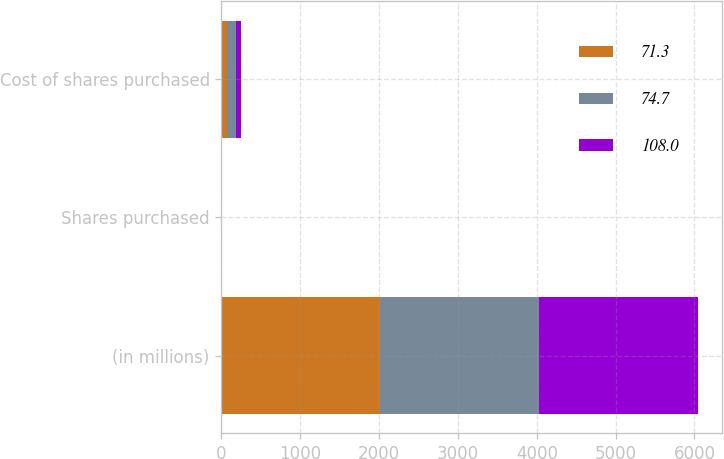Convert chart. <chart><loc_0><loc_0><loc_500><loc_500><stacked_bar_chart><ecel><fcel>(in millions)<fcel>Shares purchased<fcel>Cost of shares purchased<nl><fcel>71.3<fcel>2017<fcel>1.1<fcel>71.3<nl><fcel>74.7<fcel>2016<fcel>1.8<fcel>108<nl><fcel>108<fcel>2015<fcel>1.5<fcel>74.7<nl></chart> 